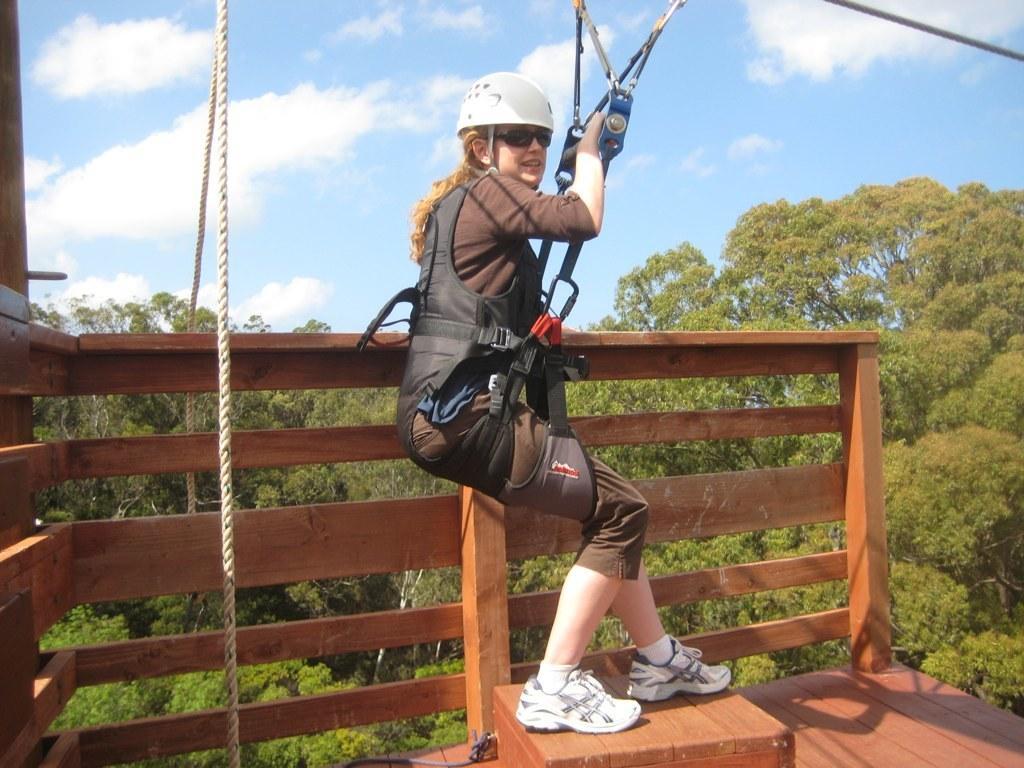Can you describe this image briefly? The woman in the middle of the picture wearing a black shirt and white helmet is hanging with the help of the rope. At the bottom of the picture, we see a wooden block. Beside her, we see a wooden railing. There are trees in the background. At the top of the picture, we see the sky and the clouds. 